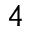<formula> <loc_0><loc_0><loc_500><loc_500>4</formula> 